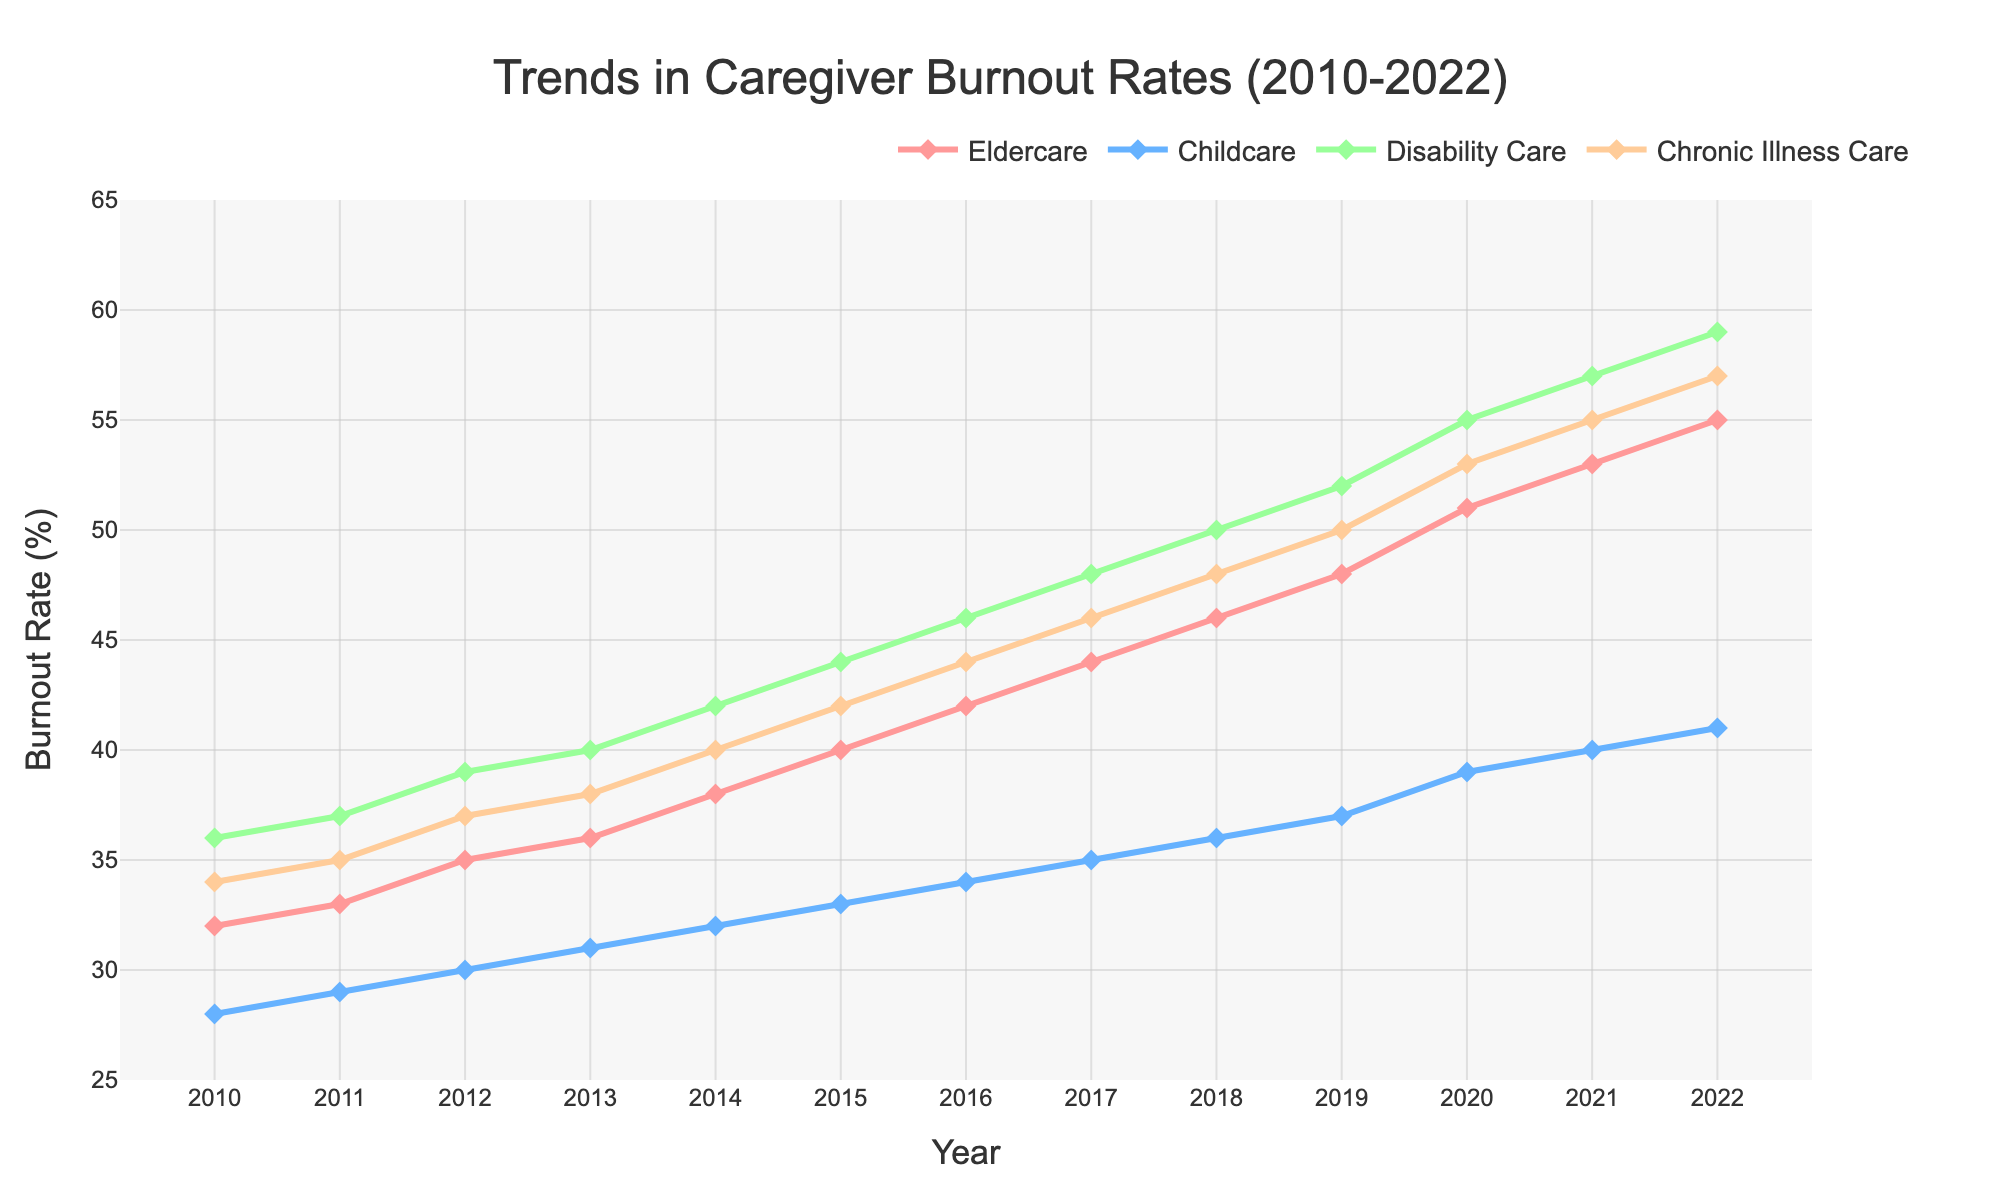What year did the burnout rate for Elder Care surpass 50%? The graph shows that the burnout rate for Elder Care is above 50% starting in 2020. Before 2020, the rate is below 50%.
Answer: 2020 Which type of care had the lowest burnout rate in 2012? By comparing all the categories for the year 2012 on the chart, Childcare has the lowest burnout rate, which is 30%.
Answer: Childcare Calculate the average burnout rate for Chronic Illness Care from 2015 to 2017. The burnout rates for Chronic Illness Care from 2015 to 2017 are 42%, 44%, and 46%. The sum of these values is 132%, and the average is 132/3 = 44%.
Answer: 44% What is the difference in burnout rates between Disability Care and Childcare in 2022? In 2022, Disability Care has a burnout rate of 59%, and Childcare has a burnout rate of 41%. The difference is 59% - 41% = 18%.
Answer: 18% Which type of care shows the steepest increase in burnout rates from 2010 to 2022? By visually evaluating the slopes of the lines for each type of care from 2010 to 2022, Disability Care shows the steepest increase. The rate goes from 36% to 59%, which is a total increase of 23%. No other category has a higher increase.
Answer: Disability Care Compare the burnout rates for Elder Care and Chronic Illness Care in 2016. Which one is higher? In 2016, Elder Care has a burnout rate of 42%, and Chronic Illness Care has a burnout rate of 44%. Comparing the two, Chronic Illness Care has a higher burnout rate.
Answer: Chronic Illness Care What is the median burnout rate of Childcare over the years? To find the median burnout rate for Childcare over 2010-2022, list the rates: 28, 29, 30, 31, 32, 33, 34, 35, 36, 37, 39, 40, 41. The median is the middle value, which is 34 in this case.
Answer: 34 Between 2011 and 2015, by how much did the burnout rate for Elder Care increase? The burnout rate for Elder Care in 2011 was 33% and in 2015 it was 40%. The increase is 40% - 33% = 7%.
Answer: 7% Which type of care shows the smallest increase in burnout rate from 2010 to 2017? From 2010 to 2017, Childcare increased from 28% to 35%, which is a total increase of 7%. This is the smallest increase among all the categories.
Answer: Childcare 